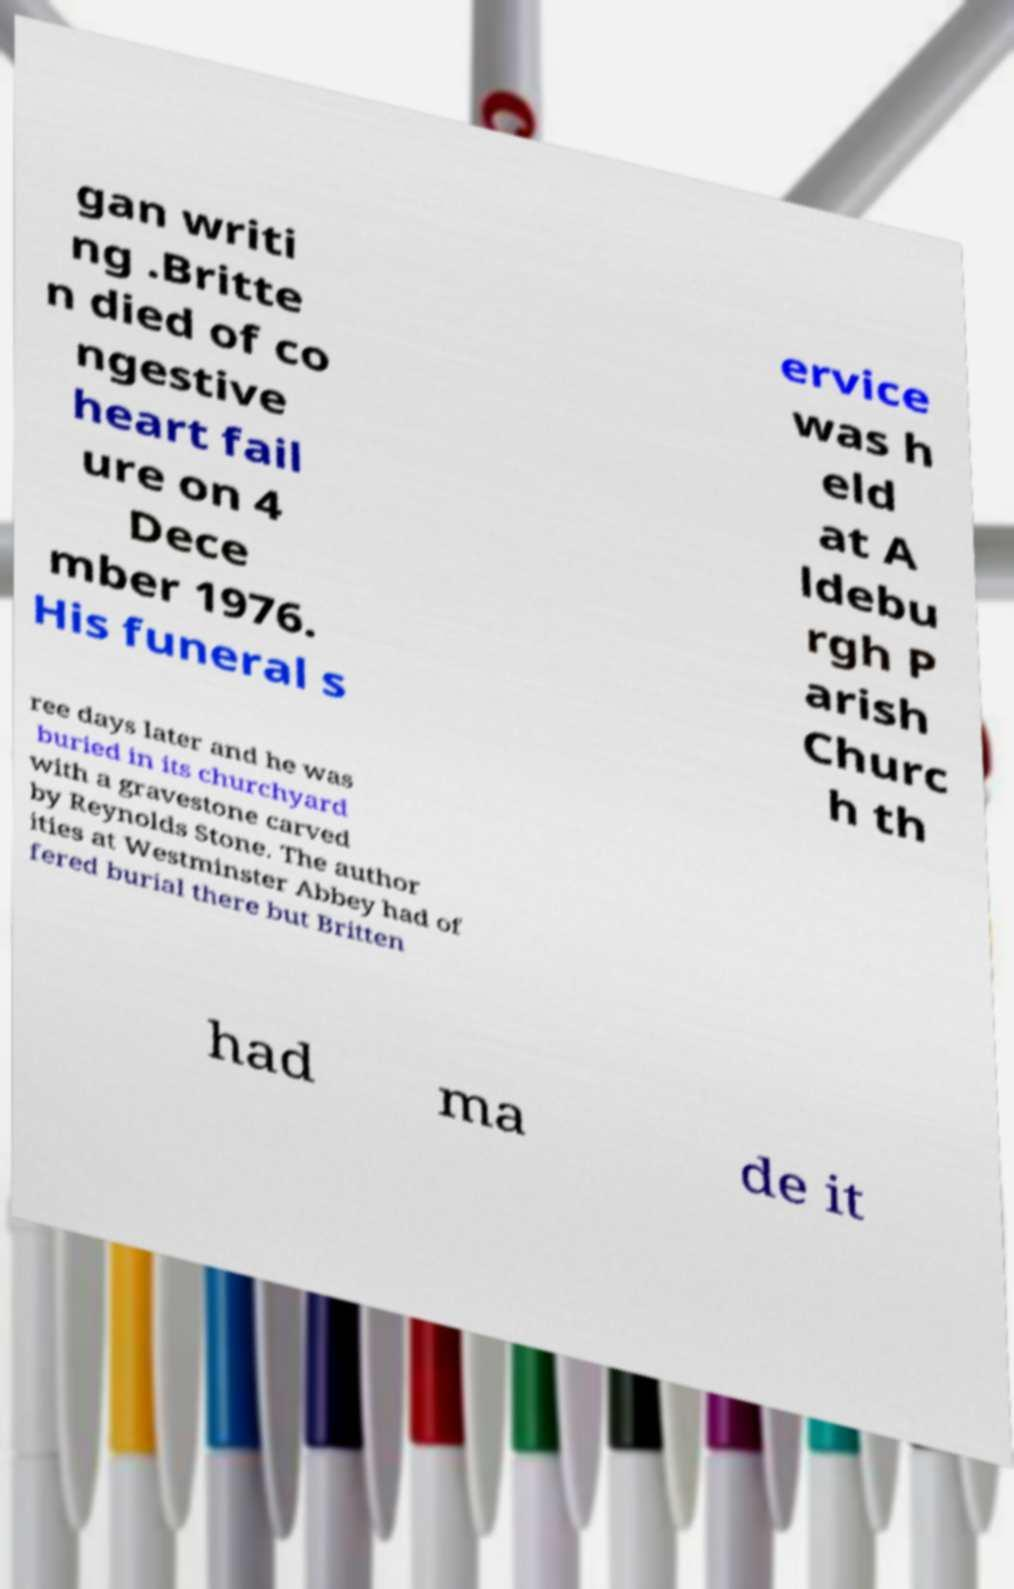Can you read and provide the text displayed in the image?This photo seems to have some interesting text. Can you extract and type it out for me? gan writi ng .Britte n died of co ngestive heart fail ure on 4 Dece mber 1976. His funeral s ervice was h eld at A ldebu rgh P arish Churc h th ree days later and he was buried in its churchyard with a gravestone carved by Reynolds Stone. The author ities at Westminster Abbey had of fered burial there but Britten had ma de it 